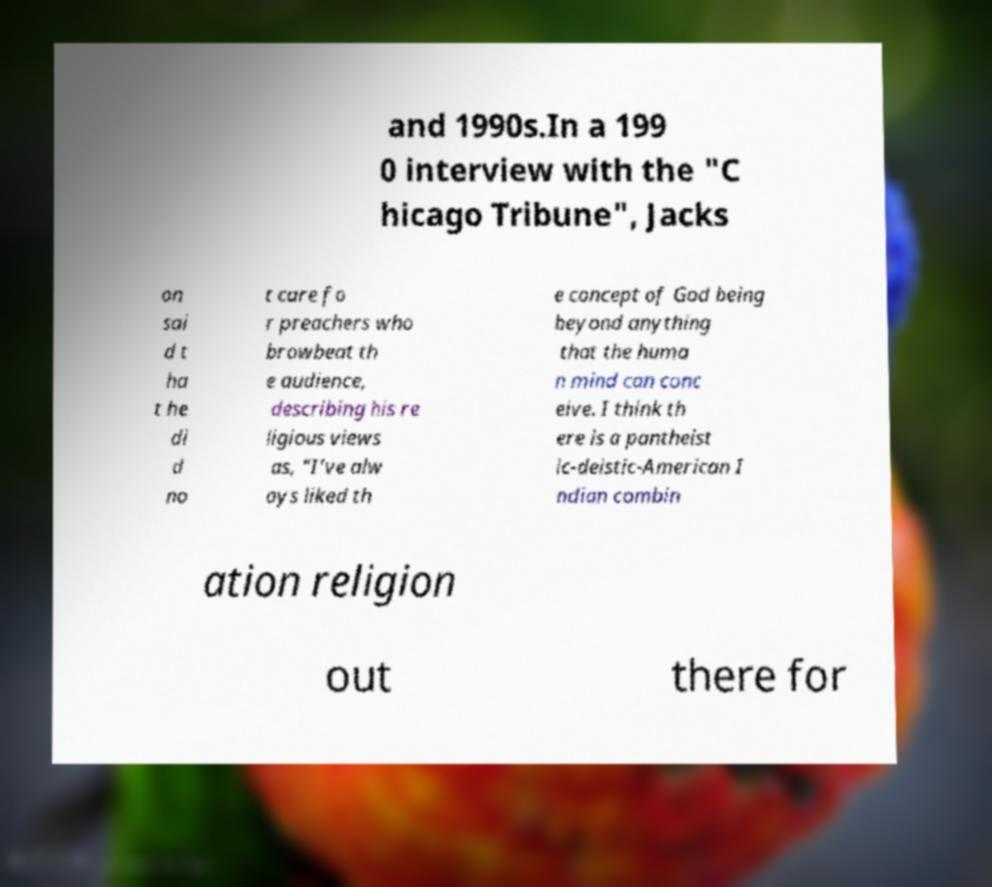Could you extract and type out the text from this image? and 1990s.In a 199 0 interview with the "C hicago Tribune", Jacks on sai d t ha t he di d no t care fo r preachers who browbeat th e audience, describing his re ligious views as, "I’ve alw ays liked th e concept of God being beyond anything that the huma n mind can conc eive. I think th ere is a pantheist ic-deistic-American I ndian combin ation religion out there for 